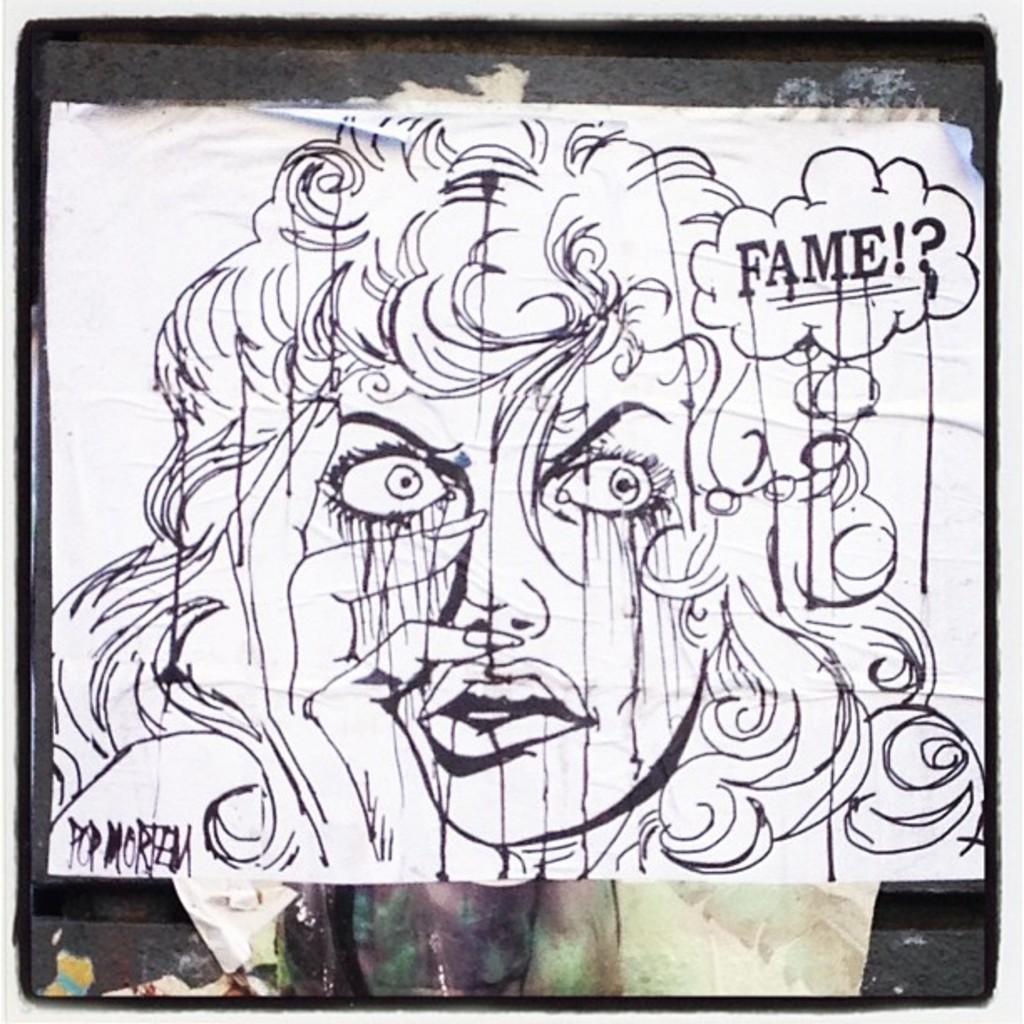Could you give a brief overview of what you see in this image? In the image in the center we can see one poster. On the poster,we can see one human face and we can see something written on it. And we can see black color border around the image. 